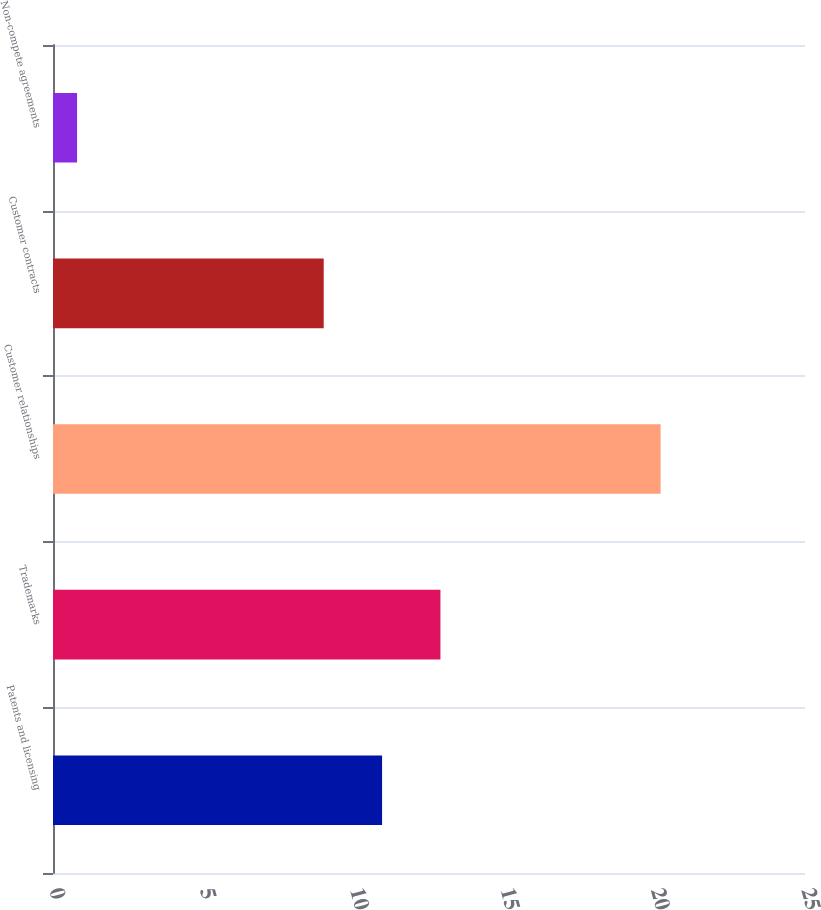Convert chart to OTSL. <chart><loc_0><loc_0><loc_500><loc_500><bar_chart><fcel>Patents and licensing<fcel>Trademarks<fcel>Customer relationships<fcel>Customer contracts<fcel>Non-compete agreements<nl><fcel>10.94<fcel>12.88<fcel>20.2<fcel>9<fcel>0.8<nl></chart> 